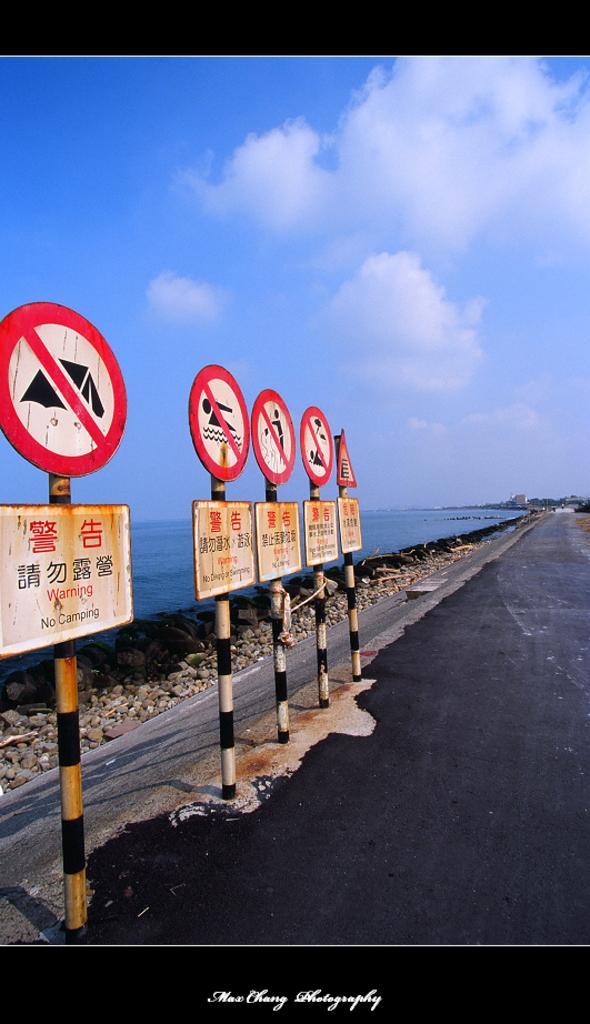What is the very first sign say not to do?
Provide a succinct answer. No camping. Are seen symbols?
Give a very brief answer. Yes. 